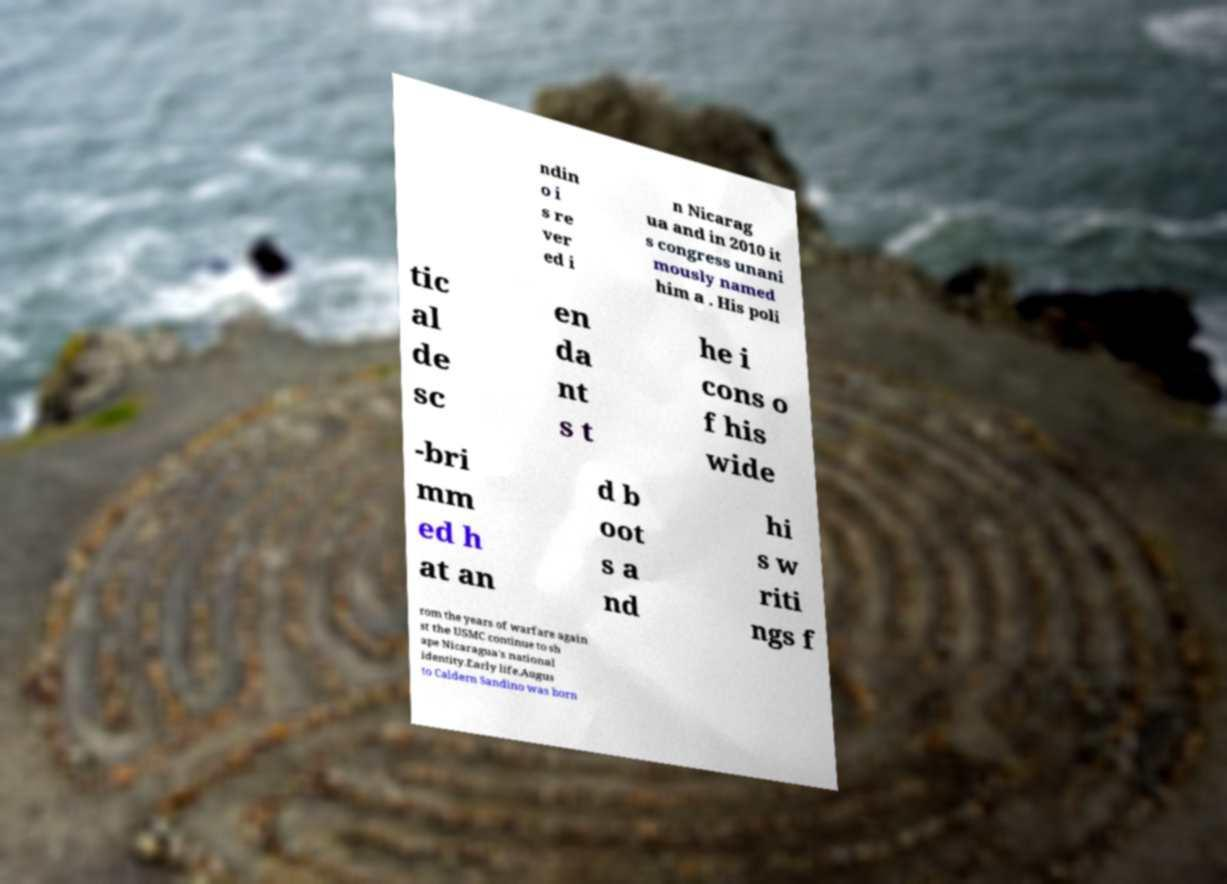Please read and relay the text visible in this image. What does it say? ndin o i s re ver ed i n Nicarag ua and in 2010 it s congress unani mously named him a . His poli tic al de sc en da nt s t he i cons o f his wide -bri mm ed h at an d b oot s a nd hi s w riti ngs f rom the years of warfare again st the USMC continue to sh ape Nicaragua's national identity.Early life.Augus to Caldern Sandino was born 